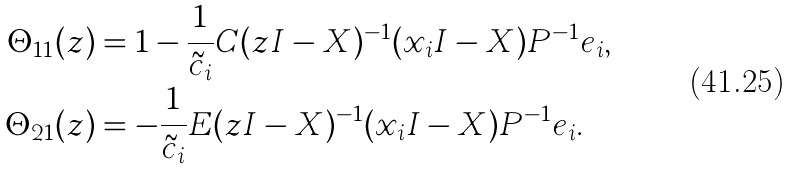<formula> <loc_0><loc_0><loc_500><loc_500>\Theta _ { 1 1 } ( z ) & = 1 - \frac { 1 } { \tilde { c } _ { i } } C ( z I - X ) ^ { - 1 } ( x _ { i } I - X ) P ^ { - 1 } e _ { i } , \\ \Theta _ { 2 1 } ( z ) & = - \frac { 1 } { \tilde { c } _ { i } } E ( z I - X ) ^ { - 1 } ( x _ { i } I - X ) P ^ { - 1 } e _ { i } .</formula> 